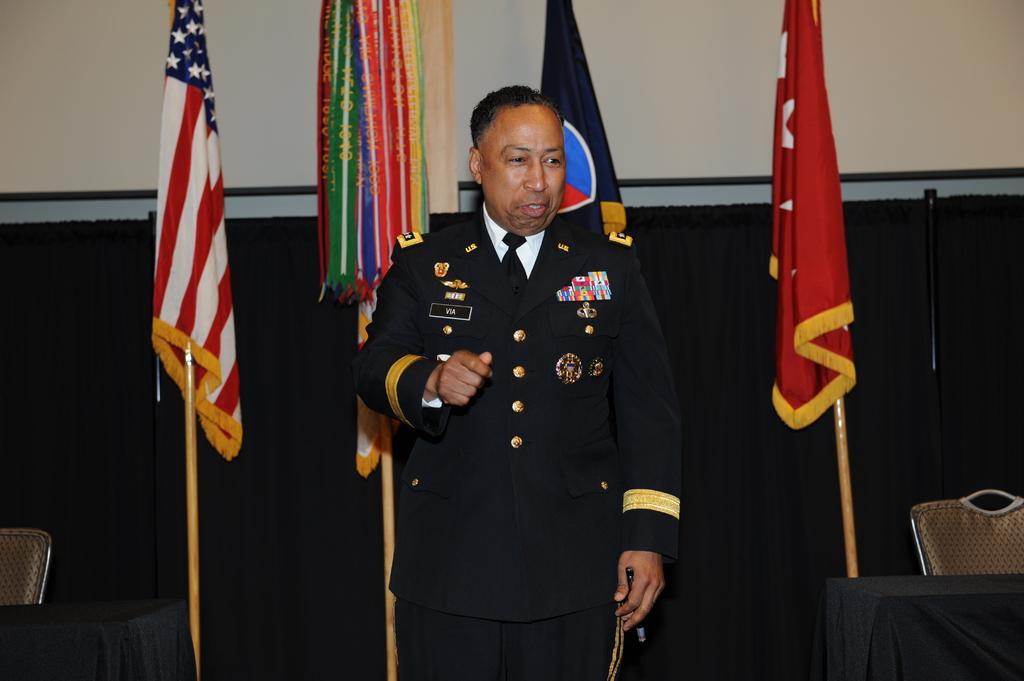How would you summarize this image in a sentence or two? In the picture I can see a man is standing. The man is wearing a uniform. In the background I can see flags, a wall and some other objects. 